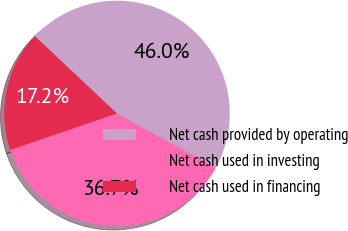Convert chart to OTSL. <chart><loc_0><loc_0><loc_500><loc_500><pie_chart><fcel>Net cash provided by operating<fcel>Net cash used in investing<fcel>Net cash used in financing<nl><fcel>46.01%<fcel>36.74%<fcel>17.25%<nl></chart> 